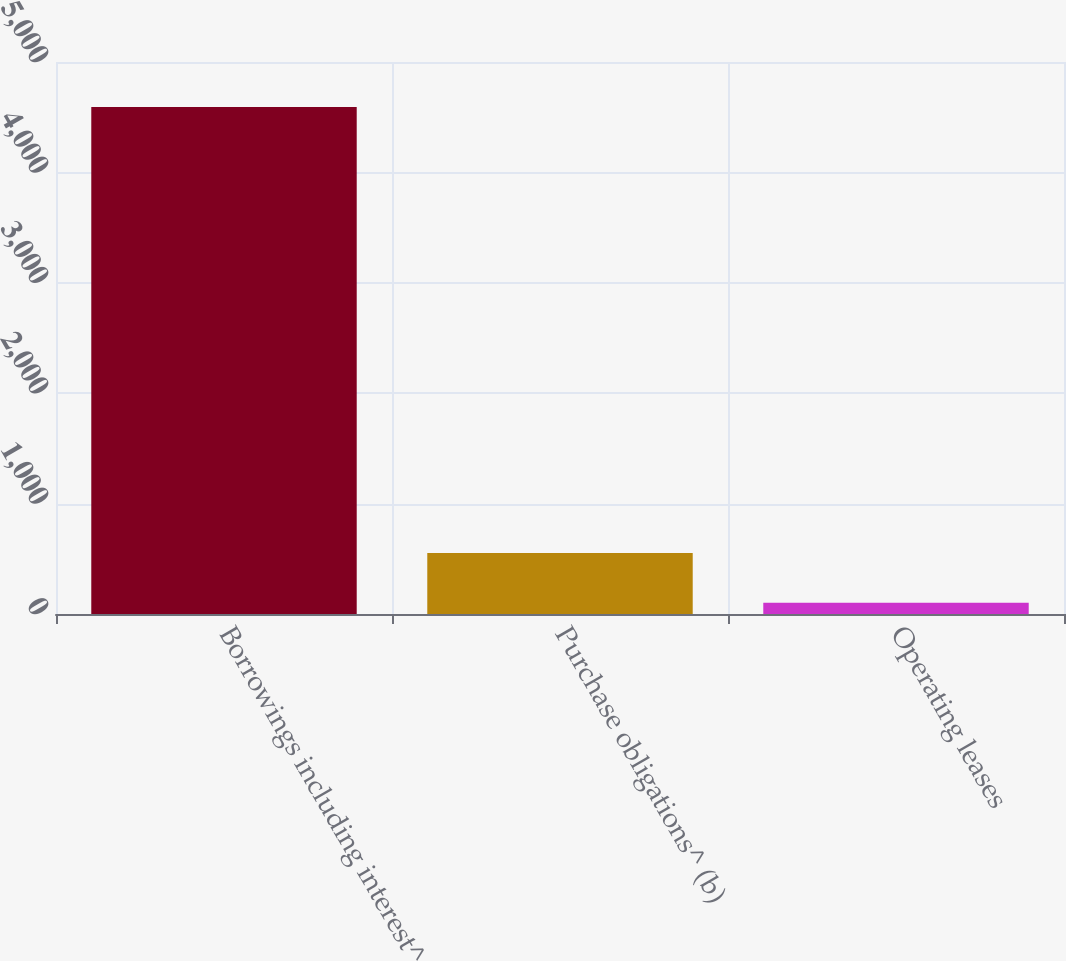<chart> <loc_0><loc_0><loc_500><loc_500><bar_chart><fcel>Borrowings including interest^<fcel>Purchase obligations^ (b)<fcel>Operating leases<nl><fcel>4593<fcel>551.64<fcel>102.6<nl></chart> 